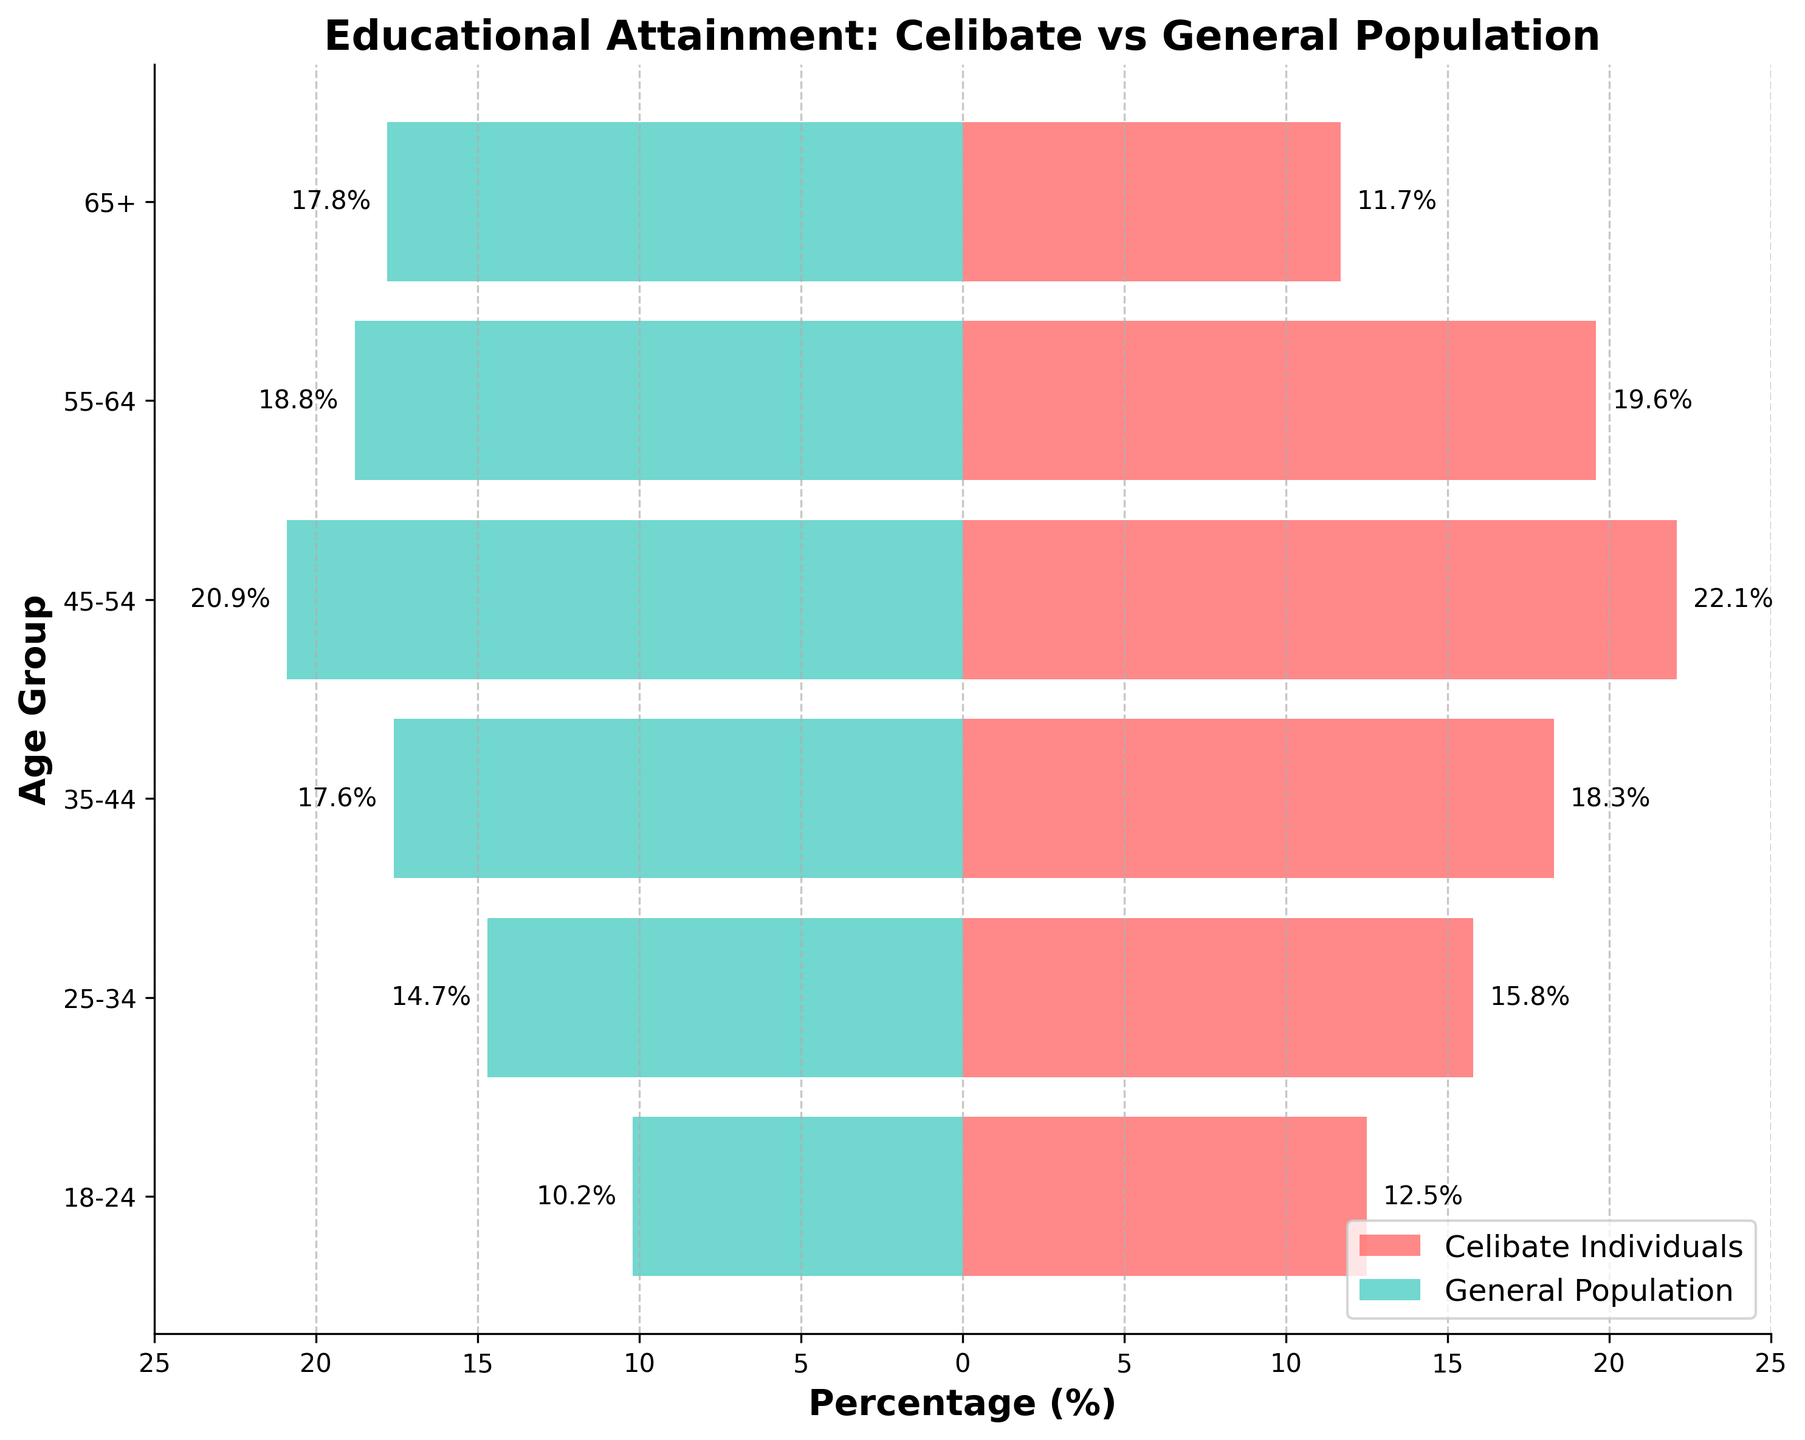What is the title of the plot? The title is given at the top of the plot; it reads: "Educational Attainment: Celibate vs General Population".
Answer: Educational Attainment: Celibate vs General Population Which age group has the highest percentage of celibate individuals? To find the answer, look at the horizontal bars representing celibate individuals; the longest bar belongs to the 45-54 age group.
Answer: 45-54 What's the percentage of the general population in the 65+ age group? Check the bar on the right side labeled "65+" for the general population. It's labeled with "-17.8%".
Answer: 17.8% How does the 25-34 age group's percentage compare between celibate individuals and the general population? For 25-34, the bar for celibate individuals ends at 15.8, while the bar for the general population ends at -14.7. This shows celibate individuals have a 1.1% higher percentage here.
Answer: Higher for celibate individuals by 1.1% Which group, celibate individuals or the general population, has a higher percentage in the 55-64 age group? Compare the length of bars for both groups in 55-64; celibate individuals have 19.6% whereas the general population has 18.8%.
Answer: Celibate individuals In the general population, which age group has the lowest percentage? Examine the lengths of the bars representing the general population; the shortest bar is for the 18-24 age group.
Answer: 18-24 For the 45-54 age group, what is the combined percentage of celibate individuals and the general population? Add the percentage of celibate individuals (22.1%) and general population (20.9%) for the age group 45-54. This sum is 22.1 + 20.9 = 43%.
Answer: 43% What is the percentage difference between celibate individuals and the general population for the age group 18-24? Subtract the general population percentage (10.2%) from the celibate individuals percentage (12.5%) for the 18-24 age group. This difference is 12.5 - 10.2 = 2.3%.
Answer: 2.3% Which age group shows a significantly lower percentage in celibate individuals compared to the general population? Identify where the bar for celibate individuals is noticeably shorter than the general population. This occurs in the 65+ age group.
Answer: 65+ Rank the age groups from highest to lowest percentage for celibate individuals. Based on bar lengths for celibate individuals, the ranking is: 45-54, 35-44, 55-64, 25-34, 18-24, and 65+.
Answer: 45-54, 35-44, 55-64, 25-34, 18-24, 65+ 